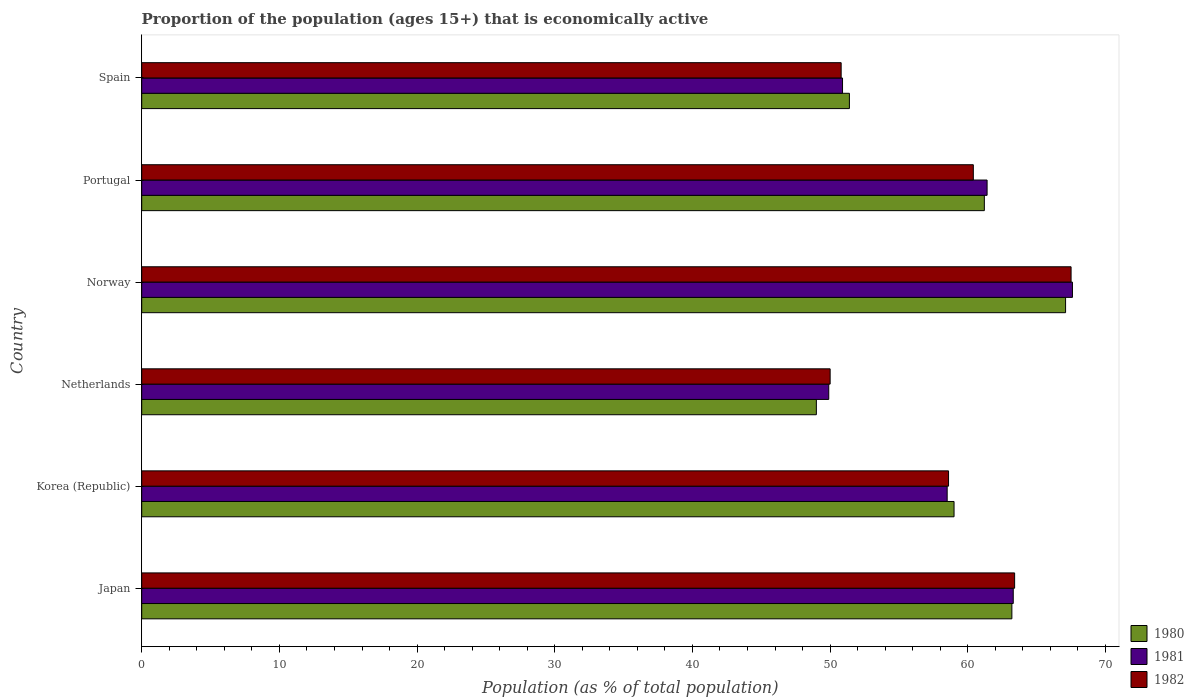How many groups of bars are there?
Provide a short and direct response. 6. Are the number of bars per tick equal to the number of legend labels?
Offer a very short reply. Yes. How many bars are there on the 6th tick from the top?
Make the answer very short. 3. In how many cases, is the number of bars for a given country not equal to the number of legend labels?
Your response must be concise. 0. What is the proportion of the population that is economically active in 1982 in Japan?
Offer a very short reply. 63.4. Across all countries, what is the maximum proportion of the population that is economically active in 1982?
Offer a very short reply. 67.5. Across all countries, what is the minimum proportion of the population that is economically active in 1981?
Give a very brief answer. 49.9. In which country was the proportion of the population that is economically active in 1980 maximum?
Your answer should be very brief. Norway. What is the total proportion of the population that is economically active in 1981 in the graph?
Offer a terse response. 351.6. What is the difference between the proportion of the population that is economically active in 1981 in Japan and that in Portugal?
Offer a very short reply. 1.9. What is the difference between the proportion of the population that is economically active in 1981 in Japan and the proportion of the population that is economically active in 1980 in Korea (Republic)?
Your answer should be compact. 4.3. What is the average proportion of the population that is economically active in 1980 per country?
Offer a terse response. 58.48. What is the difference between the proportion of the population that is economically active in 1982 and proportion of the population that is economically active in 1980 in Portugal?
Offer a terse response. -0.8. In how many countries, is the proportion of the population that is economically active in 1980 greater than 50 %?
Make the answer very short. 5. What is the ratio of the proportion of the population that is economically active in 1980 in Japan to that in Korea (Republic)?
Provide a succinct answer. 1.07. Is the proportion of the population that is economically active in 1981 in Japan less than that in Norway?
Ensure brevity in your answer.  Yes. What is the difference between the highest and the second highest proportion of the population that is economically active in 1980?
Your answer should be very brief. 3.9. What is the difference between the highest and the lowest proportion of the population that is economically active in 1981?
Your response must be concise. 17.7. In how many countries, is the proportion of the population that is economically active in 1981 greater than the average proportion of the population that is economically active in 1981 taken over all countries?
Provide a succinct answer. 3. Is the sum of the proportion of the population that is economically active in 1980 in Norway and Spain greater than the maximum proportion of the population that is economically active in 1982 across all countries?
Your answer should be compact. Yes. What does the 2nd bar from the top in Japan represents?
Provide a succinct answer. 1981. How many countries are there in the graph?
Your response must be concise. 6. Does the graph contain grids?
Your response must be concise. No. How many legend labels are there?
Make the answer very short. 3. What is the title of the graph?
Make the answer very short. Proportion of the population (ages 15+) that is economically active. What is the label or title of the X-axis?
Ensure brevity in your answer.  Population (as % of total population). What is the Population (as % of total population) in 1980 in Japan?
Your answer should be very brief. 63.2. What is the Population (as % of total population) in 1981 in Japan?
Keep it short and to the point. 63.3. What is the Population (as % of total population) in 1982 in Japan?
Offer a very short reply. 63.4. What is the Population (as % of total population) of 1980 in Korea (Republic)?
Your answer should be compact. 59. What is the Population (as % of total population) of 1981 in Korea (Republic)?
Give a very brief answer. 58.5. What is the Population (as % of total population) of 1982 in Korea (Republic)?
Provide a short and direct response. 58.6. What is the Population (as % of total population) of 1980 in Netherlands?
Provide a succinct answer. 49. What is the Population (as % of total population) of 1981 in Netherlands?
Make the answer very short. 49.9. What is the Population (as % of total population) of 1982 in Netherlands?
Give a very brief answer. 50. What is the Population (as % of total population) in 1980 in Norway?
Offer a terse response. 67.1. What is the Population (as % of total population) in 1981 in Norway?
Your answer should be very brief. 67.6. What is the Population (as % of total population) of 1982 in Norway?
Offer a very short reply. 67.5. What is the Population (as % of total population) in 1980 in Portugal?
Offer a very short reply. 61.2. What is the Population (as % of total population) of 1981 in Portugal?
Make the answer very short. 61.4. What is the Population (as % of total population) of 1982 in Portugal?
Your answer should be very brief. 60.4. What is the Population (as % of total population) of 1980 in Spain?
Offer a very short reply. 51.4. What is the Population (as % of total population) of 1981 in Spain?
Provide a succinct answer. 50.9. What is the Population (as % of total population) in 1982 in Spain?
Give a very brief answer. 50.8. Across all countries, what is the maximum Population (as % of total population) in 1980?
Make the answer very short. 67.1. Across all countries, what is the maximum Population (as % of total population) of 1981?
Make the answer very short. 67.6. Across all countries, what is the maximum Population (as % of total population) in 1982?
Your response must be concise. 67.5. Across all countries, what is the minimum Population (as % of total population) of 1981?
Provide a short and direct response. 49.9. What is the total Population (as % of total population) of 1980 in the graph?
Offer a terse response. 350.9. What is the total Population (as % of total population) in 1981 in the graph?
Offer a terse response. 351.6. What is the total Population (as % of total population) of 1982 in the graph?
Your response must be concise. 350.7. What is the difference between the Population (as % of total population) in 1980 in Japan and that in Korea (Republic)?
Your response must be concise. 4.2. What is the difference between the Population (as % of total population) of 1981 in Japan and that in Korea (Republic)?
Provide a short and direct response. 4.8. What is the difference between the Population (as % of total population) of 1982 in Japan and that in Korea (Republic)?
Ensure brevity in your answer.  4.8. What is the difference between the Population (as % of total population) of 1980 in Japan and that in Netherlands?
Make the answer very short. 14.2. What is the difference between the Population (as % of total population) in 1981 in Japan and that in Norway?
Keep it short and to the point. -4.3. What is the difference between the Population (as % of total population) of 1980 in Japan and that in Portugal?
Offer a very short reply. 2. What is the difference between the Population (as % of total population) in 1982 in Japan and that in Portugal?
Give a very brief answer. 3. What is the difference between the Population (as % of total population) of 1982 in Japan and that in Spain?
Keep it short and to the point. 12.6. What is the difference between the Population (as % of total population) in 1980 in Korea (Republic) and that in Netherlands?
Keep it short and to the point. 10. What is the difference between the Population (as % of total population) in 1981 in Korea (Republic) and that in Netherlands?
Your answer should be compact. 8.6. What is the difference between the Population (as % of total population) in 1982 in Korea (Republic) and that in Netherlands?
Offer a very short reply. 8.6. What is the difference between the Population (as % of total population) of 1981 in Korea (Republic) and that in Norway?
Give a very brief answer. -9.1. What is the difference between the Population (as % of total population) of 1982 in Korea (Republic) and that in Norway?
Your answer should be very brief. -8.9. What is the difference between the Population (as % of total population) of 1981 in Korea (Republic) and that in Portugal?
Your answer should be very brief. -2.9. What is the difference between the Population (as % of total population) in 1980 in Korea (Republic) and that in Spain?
Provide a succinct answer. 7.6. What is the difference between the Population (as % of total population) in 1982 in Korea (Republic) and that in Spain?
Your answer should be compact. 7.8. What is the difference between the Population (as % of total population) in 1980 in Netherlands and that in Norway?
Provide a short and direct response. -18.1. What is the difference between the Population (as % of total population) of 1981 in Netherlands and that in Norway?
Your answer should be compact. -17.7. What is the difference between the Population (as % of total population) in 1982 in Netherlands and that in Norway?
Ensure brevity in your answer.  -17.5. What is the difference between the Population (as % of total population) of 1982 in Netherlands and that in Portugal?
Keep it short and to the point. -10.4. What is the difference between the Population (as % of total population) in 1980 in Netherlands and that in Spain?
Your response must be concise. -2.4. What is the difference between the Population (as % of total population) in 1981 in Netherlands and that in Spain?
Ensure brevity in your answer.  -1. What is the difference between the Population (as % of total population) in 1980 in Norway and that in Portugal?
Your response must be concise. 5.9. What is the difference between the Population (as % of total population) of 1981 in Portugal and that in Spain?
Keep it short and to the point. 10.5. What is the difference between the Population (as % of total population) of 1981 in Japan and the Population (as % of total population) of 1982 in Korea (Republic)?
Make the answer very short. 4.7. What is the difference between the Population (as % of total population) of 1980 in Japan and the Population (as % of total population) of 1982 in Netherlands?
Give a very brief answer. 13.2. What is the difference between the Population (as % of total population) of 1980 in Japan and the Population (as % of total population) of 1981 in Norway?
Offer a terse response. -4.4. What is the difference between the Population (as % of total population) of 1980 in Japan and the Population (as % of total population) of 1982 in Norway?
Provide a succinct answer. -4.3. What is the difference between the Population (as % of total population) of 1981 in Japan and the Population (as % of total population) of 1982 in Norway?
Make the answer very short. -4.2. What is the difference between the Population (as % of total population) of 1980 in Japan and the Population (as % of total population) of 1981 in Portugal?
Provide a short and direct response. 1.8. What is the difference between the Population (as % of total population) in 1981 in Japan and the Population (as % of total population) in 1982 in Portugal?
Keep it short and to the point. 2.9. What is the difference between the Population (as % of total population) in 1980 in Japan and the Population (as % of total population) in 1982 in Spain?
Ensure brevity in your answer.  12.4. What is the difference between the Population (as % of total population) in 1981 in Japan and the Population (as % of total population) in 1982 in Spain?
Your answer should be very brief. 12.5. What is the difference between the Population (as % of total population) in 1980 in Korea (Republic) and the Population (as % of total population) in 1981 in Netherlands?
Ensure brevity in your answer.  9.1. What is the difference between the Population (as % of total population) in 1981 in Korea (Republic) and the Population (as % of total population) in 1982 in Netherlands?
Your answer should be very brief. 8.5. What is the difference between the Population (as % of total population) in 1980 in Korea (Republic) and the Population (as % of total population) in 1981 in Norway?
Make the answer very short. -8.6. What is the difference between the Population (as % of total population) in 1980 in Korea (Republic) and the Population (as % of total population) in 1982 in Norway?
Provide a short and direct response. -8.5. What is the difference between the Population (as % of total population) in 1981 in Korea (Republic) and the Population (as % of total population) in 1982 in Norway?
Keep it short and to the point. -9. What is the difference between the Population (as % of total population) in 1980 in Korea (Republic) and the Population (as % of total population) in 1981 in Portugal?
Your response must be concise. -2.4. What is the difference between the Population (as % of total population) of 1981 in Korea (Republic) and the Population (as % of total population) of 1982 in Portugal?
Provide a succinct answer. -1.9. What is the difference between the Population (as % of total population) of 1981 in Korea (Republic) and the Population (as % of total population) of 1982 in Spain?
Keep it short and to the point. 7.7. What is the difference between the Population (as % of total population) in 1980 in Netherlands and the Population (as % of total population) in 1981 in Norway?
Your answer should be very brief. -18.6. What is the difference between the Population (as % of total population) of 1980 in Netherlands and the Population (as % of total population) of 1982 in Norway?
Provide a succinct answer. -18.5. What is the difference between the Population (as % of total population) of 1981 in Netherlands and the Population (as % of total population) of 1982 in Norway?
Your answer should be compact. -17.6. What is the difference between the Population (as % of total population) in 1980 in Netherlands and the Population (as % of total population) in 1981 in Portugal?
Provide a succinct answer. -12.4. What is the difference between the Population (as % of total population) of 1980 in Netherlands and the Population (as % of total population) of 1982 in Portugal?
Keep it short and to the point. -11.4. What is the difference between the Population (as % of total population) of 1980 in Netherlands and the Population (as % of total population) of 1981 in Spain?
Offer a terse response. -1.9. What is the difference between the Population (as % of total population) of 1980 in Netherlands and the Population (as % of total population) of 1982 in Spain?
Provide a short and direct response. -1.8. What is the difference between the Population (as % of total population) in 1980 in Norway and the Population (as % of total population) in 1981 in Portugal?
Provide a succinct answer. 5.7. What is the difference between the Population (as % of total population) in 1980 in Norway and the Population (as % of total population) in 1982 in Portugal?
Keep it short and to the point. 6.7. What is the difference between the Population (as % of total population) of 1980 in Norway and the Population (as % of total population) of 1981 in Spain?
Provide a short and direct response. 16.2. What is the difference between the Population (as % of total population) in 1981 in Norway and the Population (as % of total population) in 1982 in Spain?
Give a very brief answer. 16.8. What is the difference between the Population (as % of total population) in 1981 in Portugal and the Population (as % of total population) in 1982 in Spain?
Ensure brevity in your answer.  10.6. What is the average Population (as % of total population) of 1980 per country?
Make the answer very short. 58.48. What is the average Population (as % of total population) in 1981 per country?
Keep it short and to the point. 58.6. What is the average Population (as % of total population) in 1982 per country?
Offer a terse response. 58.45. What is the difference between the Population (as % of total population) of 1980 and Population (as % of total population) of 1982 in Japan?
Offer a terse response. -0.2. What is the difference between the Population (as % of total population) in 1981 and Population (as % of total population) in 1982 in Japan?
Your answer should be very brief. -0.1. What is the difference between the Population (as % of total population) in 1980 and Population (as % of total population) in 1981 in Korea (Republic)?
Offer a very short reply. 0.5. What is the difference between the Population (as % of total population) of 1981 and Population (as % of total population) of 1982 in Netherlands?
Provide a short and direct response. -0.1. What is the difference between the Population (as % of total population) in 1980 and Population (as % of total population) in 1981 in Norway?
Provide a short and direct response. -0.5. What is the difference between the Population (as % of total population) of 1980 and Population (as % of total population) of 1982 in Norway?
Provide a succinct answer. -0.4. What is the difference between the Population (as % of total population) in 1980 and Population (as % of total population) in 1981 in Portugal?
Offer a terse response. -0.2. What is the ratio of the Population (as % of total population) of 1980 in Japan to that in Korea (Republic)?
Your answer should be compact. 1.07. What is the ratio of the Population (as % of total population) of 1981 in Japan to that in Korea (Republic)?
Ensure brevity in your answer.  1.08. What is the ratio of the Population (as % of total population) of 1982 in Japan to that in Korea (Republic)?
Keep it short and to the point. 1.08. What is the ratio of the Population (as % of total population) of 1980 in Japan to that in Netherlands?
Provide a short and direct response. 1.29. What is the ratio of the Population (as % of total population) in 1981 in Japan to that in Netherlands?
Provide a short and direct response. 1.27. What is the ratio of the Population (as % of total population) in 1982 in Japan to that in Netherlands?
Your answer should be compact. 1.27. What is the ratio of the Population (as % of total population) of 1980 in Japan to that in Norway?
Keep it short and to the point. 0.94. What is the ratio of the Population (as % of total population) of 1981 in Japan to that in Norway?
Your answer should be very brief. 0.94. What is the ratio of the Population (as % of total population) in 1982 in Japan to that in Norway?
Ensure brevity in your answer.  0.94. What is the ratio of the Population (as % of total population) in 1980 in Japan to that in Portugal?
Your answer should be compact. 1.03. What is the ratio of the Population (as % of total population) of 1981 in Japan to that in Portugal?
Offer a terse response. 1.03. What is the ratio of the Population (as % of total population) in 1982 in Japan to that in Portugal?
Your response must be concise. 1.05. What is the ratio of the Population (as % of total population) of 1980 in Japan to that in Spain?
Offer a very short reply. 1.23. What is the ratio of the Population (as % of total population) of 1981 in Japan to that in Spain?
Your response must be concise. 1.24. What is the ratio of the Population (as % of total population) in 1982 in Japan to that in Spain?
Your answer should be compact. 1.25. What is the ratio of the Population (as % of total population) of 1980 in Korea (Republic) to that in Netherlands?
Give a very brief answer. 1.2. What is the ratio of the Population (as % of total population) of 1981 in Korea (Republic) to that in Netherlands?
Offer a terse response. 1.17. What is the ratio of the Population (as % of total population) of 1982 in Korea (Republic) to that in Netherlands?
Provide a short and direct response. 1.17. What is the ratio of the Population (as % of total population) of 1980 in Korea (Republic) to that in Norway?
Keep it short and to the point. 0.88. What is the ratio of the Population (as % of total population) of 1981 in Korea (Republic) to that in Norway?
Keep it short and to the point. 0.87. What is the ratio of the Population (as % of total population) of 1982 in Korea (Republic) to that in Norway?
Make the answer very short. 0.87. What is the ratio of the Population (as % of total population) of 1980 in Korea (Republic) to that in Portugal?
Give a very brief answer. 0.96. What is the ratio of the Population (as % of total population) in 1981 in Korea (Republic) to that in Portugal?
Your answer should be very brief. 0.95. What is the ratio of the Population (as % of total population) of 1982 in Korea (Republic) to that in Portugal?
Offer a terse response. 0.97. What is the ratio of the Population (as % of total population) in 1980 in Korea (Republic) to that in Spain?
Ensure brevity in your answer.  1.15. What is the ratio of the Population (as % of total population) in 1981 in Korea (Republic) to that in Spain?
Your response must be concise. 1.15. What is the ratio of the Population (as % of total population) in 1982 in Korea (Republic) to that in Spain?
Your response must be concise. 1.15. What is the ratio of the Population (as % of total population) of 1980 in Netherlands to that in Norway?
Your answer should be very brief. 0.73. What is the ratio of the Population (as % of total population) of 1981 in Netherlands to that in Norway?
Keep it short and to the point. 0.74. What is the ratio of the Population (as % of total population) in 1982 in Netherlands to that in Norway?
Give a very brief answer. 0.74. What is the ratio of the Population (as % of total population) in 1980 in Netherlands to that in Portugal?
Give a very brief answer. 0.8. What is the ratio of the Population (as % of total population) of 1981 in Netherlands to that in Portugal?
Ensure brevity in your answer.  0.81. What is the ratio of the Population (as % of total population) in 1982 in Netherlands to that in Portugal?
Your answer should be very brief. 0.83. What is the ratio of the Population (as % of total population) of 1980 in Netherlands to that in Spain?
Ensure brevity in your answer.  0.95. What is the ratio of the Population (as % of total population) in 1981 in Netherlands to that in Spain?
Give a very brief answer. 0.98. What is the ratio of the Population (as % of total population) in 1982 in Netherlands to that in Spain?
Offer a very short reply. 0.98. What is the ratio of the Population (as % of total population) in 1980 in Norway to that in Portugal?
Offer a very short reply. 1.1. What is the ratio of the Population (as % of total population) of 1981 in Norway to that in Portugal?
Offer a terse response. 1.1. What is the ratio of the Population (as % of total population) of 1982 in Norway to that in Portugal?
Give a very brief answer. 1.12. What is the ratio of the Population (as % of total population) in 1980 in Norway to that in Spain?
Your response must be concise. 1.31. What is the ratio of the Population (as % of total population) in 1981 in Norway to that in Spain?
Offer a very short reply. 1.33. What is the ratio of the Population (as % of total population) in 1982 in Norway to that in Spain?
Your answer should be very brief. 1.33. What is the ratio of the Population (as % of total population) in 1980 in Portugal to that in Spain?
Keep it short and to the point. 1.19. What is the ratio of the Population (as % of total population) in 1981 in Portugal to that in Spain?
Your response must be concise. 1.21. What is the ratio of the Population (as % of total population) in 1982 in Portugal to that in Spain?
Offer a terse response. 1.19. What is the difference between the highest and the second highest Population (as % of total population) of 1981?
Provide a succinct answer. 4.3. What is the difference between the highest and the second highest Population (as % of total population) of 1982?
Your answer should be very brief. 4.1. 